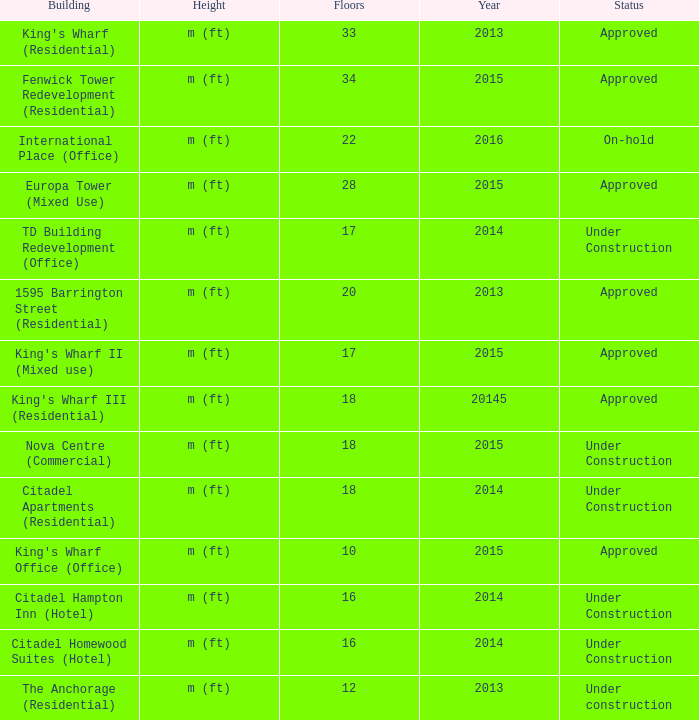What is the state of the 2014 building with 33 levels? Approved. 